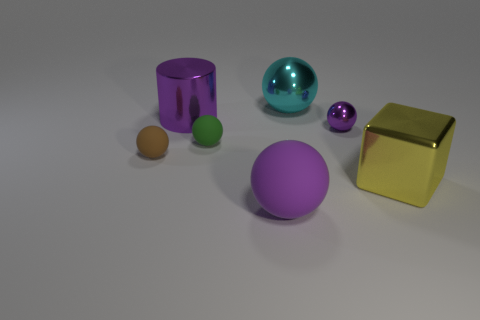Are there fewer purple metal objects that are to the right of the metallic cylinder than large balls?
Offer a very short reply. Yes. How many green things have the same size as the purple cylinder?
Provide a short and direct response. 0. What is the shape of the rubber thing that is the same color as the cylinder?
Your answer should be compact. Sphere. Does the large object to the left of the large rubber thing have the same color as the tiny thing that is on the right side of the large purple ball?
Offer a very short reply. Yes. What number of large yellow blocks are behind the big metallic cube?
Ensure brevity in your answer.  0. What size is the matte sphere that is the same color as the small shiny sphere?
Offer a terse response. Large. Is there a purple thing of the same shape as the yellow thing?
Your answer should be very brief. No. What color is the other matte thing that is the same size as the brown object?
Offer a terse response. Green. Are there fewer large metallic cubes that are behind the cyan metallic ball than tiny purple metal things that are in front of the small brown thing?
Provide a short and direct response. No. Do the thing in front of the block and the metallic cube have the same size?
Provide a succinct answer. Yes. 